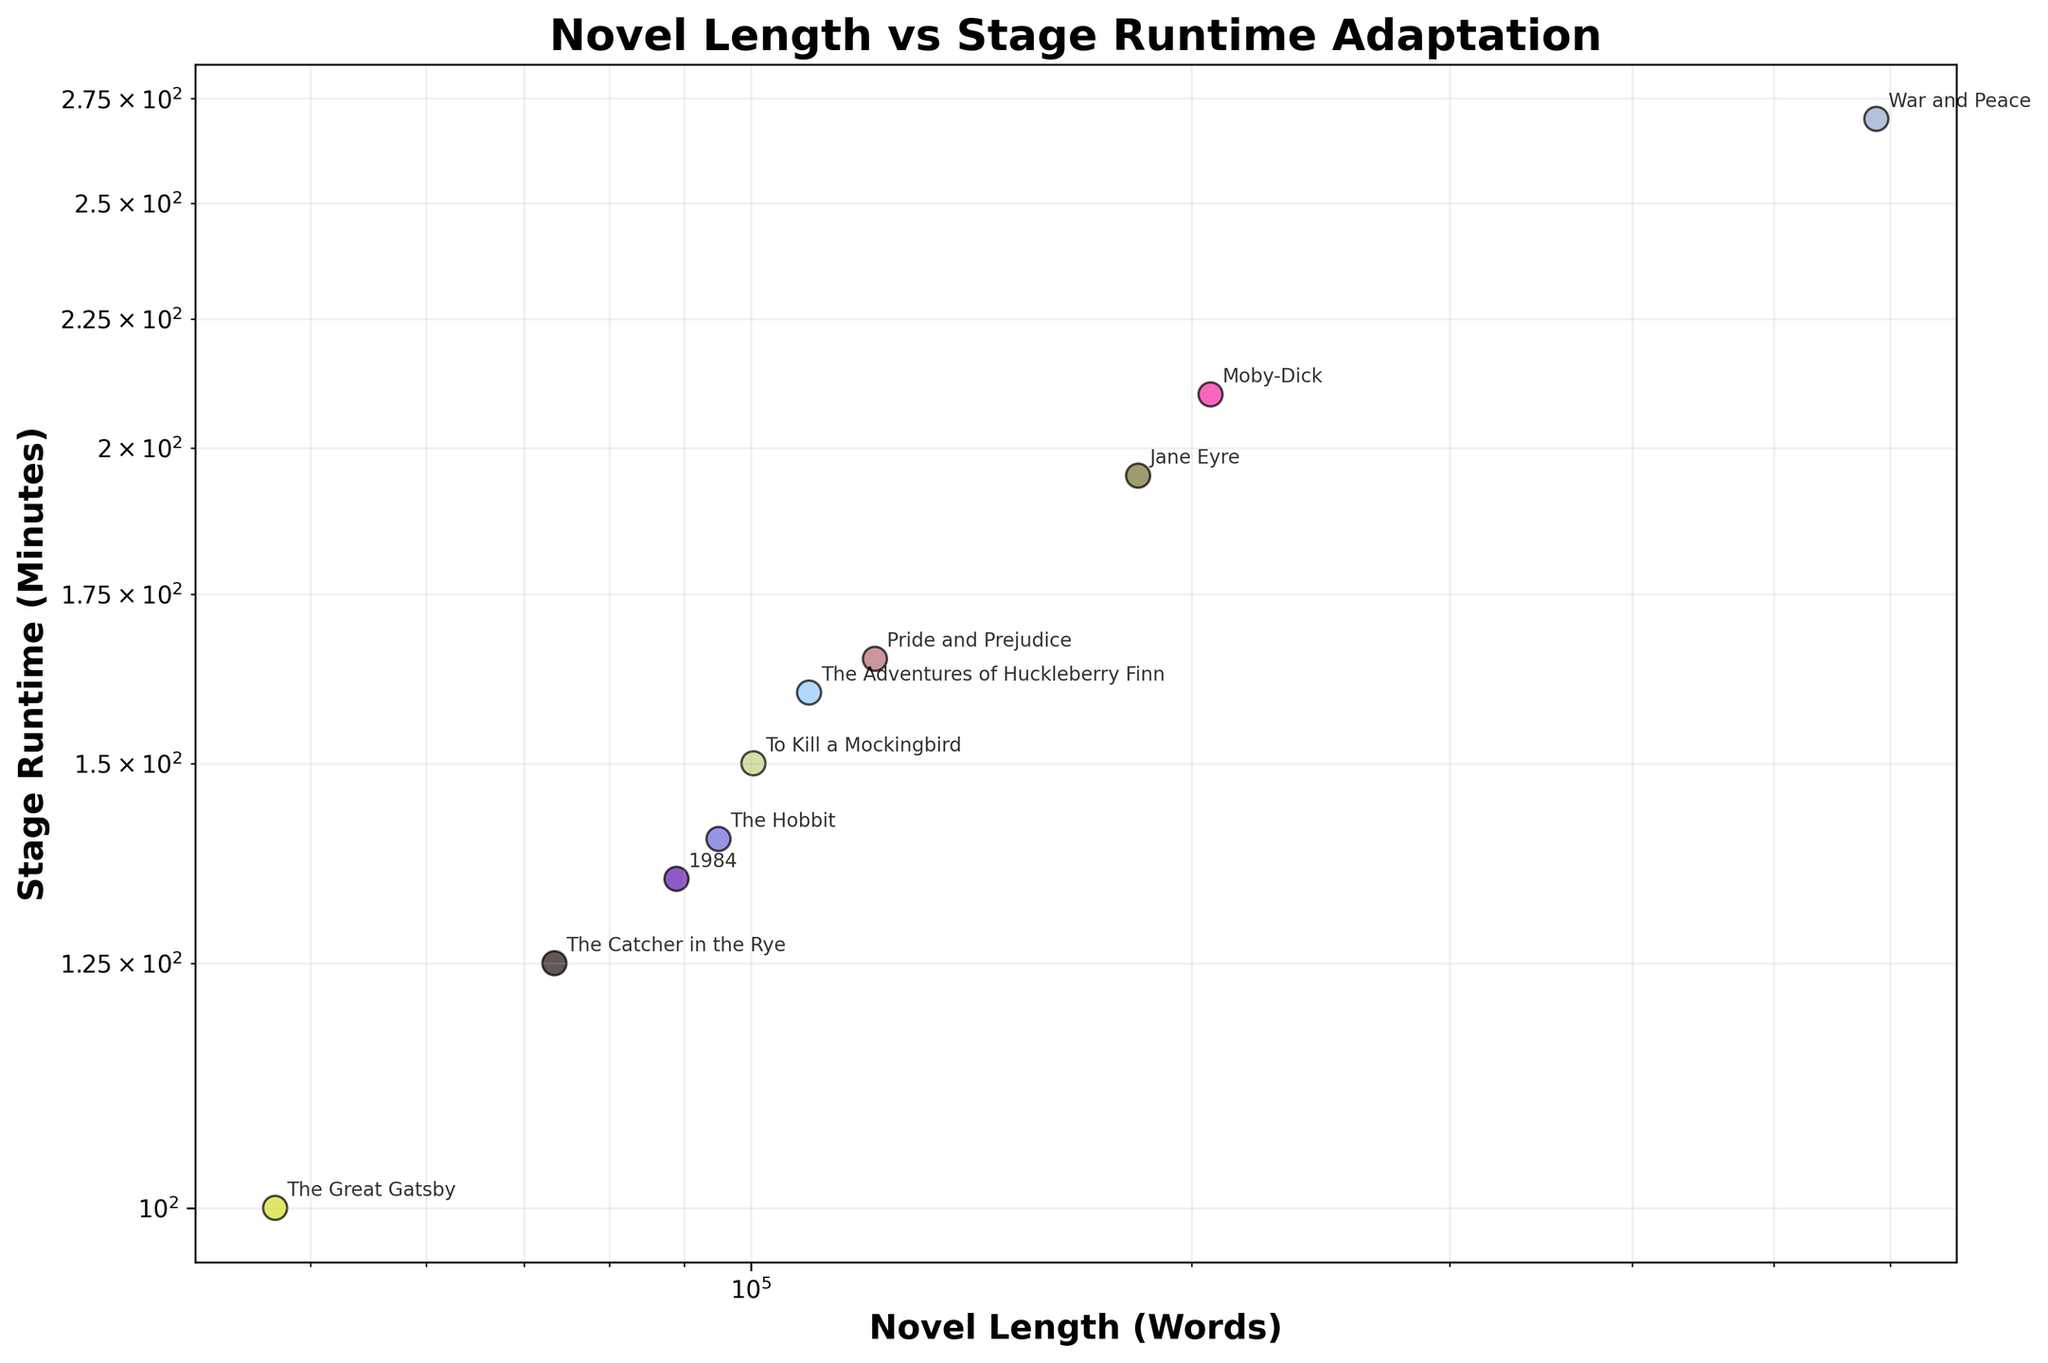What's the title of the plot? The title is usually placed at the top of the plot. In this case, it states the relationship being visualized.
Answer: Novel Length vs Stage Runtime Adaptation What do the x and y axes represent? The x-axis typically represents the independent variable, and the y-axis the dependent variable. Here, the x-axis shows 'Novel Length (Words)' and the y-axis shows 'Stage Runtime (Minutes)'.
Answer: Novel Length (Words) and Stage Runtime (Minutes) How many novels are represented in the plot? Each point in the scatter plot represents a novel. Counting the data points or checking the annotations with the titles can determine the number of novels.
Answer: 10 Which novel has the longest stage runtime adaptation? The novel with the longest stage runtime will be the one farthest to the top of the plot. According to the annotations, this is 'War and Peace'.
Answer: War and Peace Which novel has the shortest stage runtime adaptation? The novel with the shortest stage runtime will be the one farthest to the bottom of the plot. According to the annotations, this is 'The Great Gatsby'.
Answer: The Great Gatsby Compare the stage runtime of "To Kill a Mockingbird" and "The Hobbit". Which is longer? Locate both novels on the plot and compare their positions on the y-axis. "To Kill a Mockingbird" is higher on the y-axis than "The Hobbit".
Answer: To Kill a Mockingbird What is the relationship between the novel length and stage runtime adaptation? Observing the positions of the points, one can infer that as the novel length increases, stage runtime also tends to increase. This can be deduced from the fact that points with larger x-values tend to have larger y-values.
Answer: Positive correlation What's the difference in novel length between '1984' and 'War and Peace'? Find the x-values for both '1984' and 'War and Peace' and subtract the smaller value from the larger one. '1984' has about 88,942 words and 'War and Peace' has 587,287 words. The difference is 587,287 - 88,942.
Answer: 498,345 words If you grouped the novels into short (<100,000 words) and long (>=100,000 words), which group tends to have longer stage runtimes on average? Identify the novel lengths and categorize them into the two groups. Then, compare the average stage runtime for novels in each group.
Answer: Long novels Are there any outliers in the plot? If yes, which novel is an outlier? Outliers are points that deviate significantly from the general trend of the data. 'War and Peace' appears to be an outlier as it has an unusually high word count and stage runtime compared to the other novels.
Answer: War and Peace 